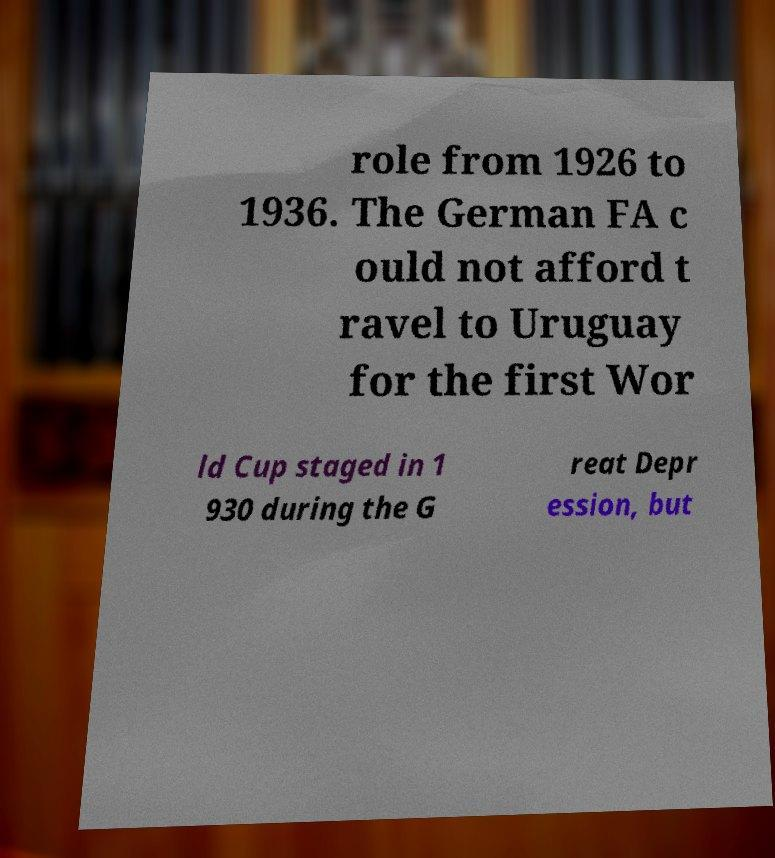For documentation purposes, I need the text within this image transcribed. Could you provide that? role from 1926 to 1936. The German FA c ould not afford t ravel to Uruguay for the first Wor ld Cup staged in 1 930 during the G reat Depr ession, but 